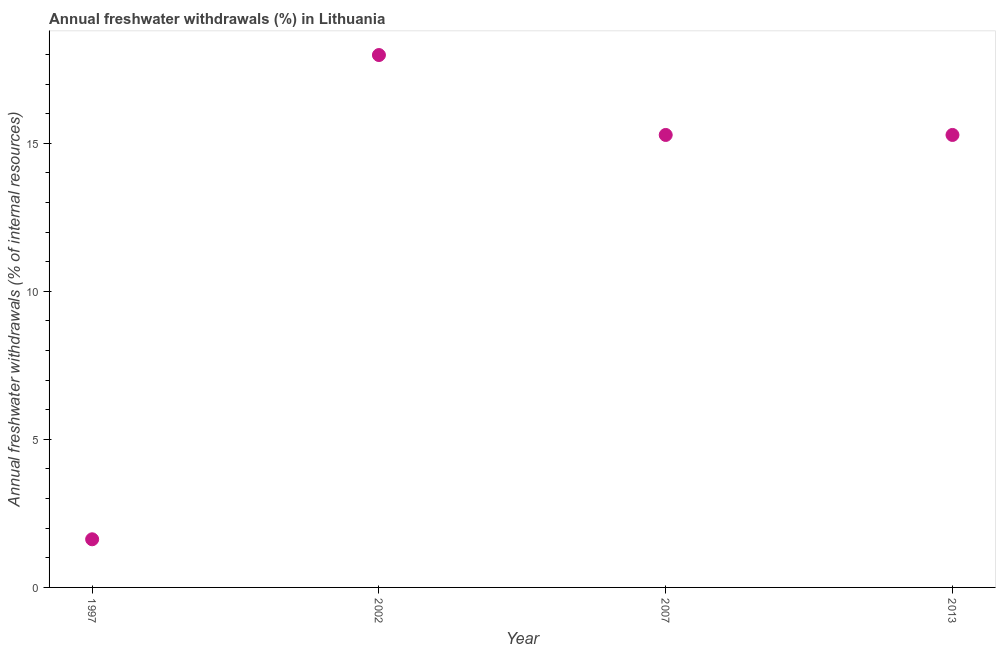What is the annual freshwater withdrawals in 2007?
Your response must be concise. 15.28. Across all years, what is the maximum annual freshwater withdrawals?
Provide a short and direct response. 17.98. Across all years, what is the minimum annual freshwater withdrawals?
Keep it short and to the point. 1.63. In which year was the annual freshwater withdrawals minimum?
Offer a terse response. 1997. What is the sum of the annual freshwater withdrawals?
Your answer should be compact. 50.17. What is the average annual freshwater withdrawals per year?
Offer a very short reply. 12.54. What is the median annual freshwater withdrawals?
Your answer should be compact. 15.28. In how many years, is the annual freshwater withdrawals greater than 13 %?
Your answer should be compact. 3. Is the annual freshwater withdrawals in 1997 less than that in 2002?
Make the answer very short. Yes. Is the difference between the annual freshwater withdrawals in 1997 and 2013 greater than the difference between any two years?
Offer a very short reply. No. What is the difference between the highest and the second highest annual freshwater withdrawals?
Provide a short and direct response. 2.7. What is the difference between the highest and the lowest annual freshwater withdrawals?
Make the answer very short. 16.36. Does the annual freshwater withdrawals monotonically increase over the years?
Offer a very short reply. No. How many dotlines are there?
Offer a terse response. 1. How many years are there in the graph?
Your response must be concise. 4. Are the values on the major ticks of Y-axis written in scientific E-notation?
Ensure brevity in your answer.  No. Does the graph contain grids?
Provide a succinct answer. No. What is the title of the graph?
Your response must be concise. Annual freshwater withdrawals (%) in Lithuania. What is the label or title of the Y-axis?
Provide a succinct answer. Annual freshwater withdrawals (% of internal resources). What is the Annual freshwater withdrawals (% of internal resources) in 1997?
Your answer should be very brief. 1.63. What is the Annual freshwater withdrawals (% of internal resources) in 2002?
Your response must be concise. 17.98. What is the Annual freshwater withdrawals (% of internal resources) in 2007?
Give a very brief answer. 15.28. What is the Annual freshwater withdrawals (% of internal resources) in 2013?
Your answer should be compact. 15.28. What is the difference between the Annual freshwater withdrawals (% of internal resources) in 1997 and 2002?
Your response must be concise. -16.36. What is the difference between the Annual freshwater withdrawals (% of internal resources) in 1997 and 2007?
Ensure brevity in your answer.  -13.66. What is the difference between the Annual freshwater withdrawals (% of internal resources) in 1997 and 2013?
Provide a short and direct response. -13.66. What is the difference between the Annual freshwater withdrawals (% of internal resources) in 2002 and 2007?
Provide a succinct answer. 2.7. What is the difference between the Annual freshwater withdrawals (% of internal resources) in 2002 and 2013?
Provide a succinct answer. 2.7. What is the ratio of the Annual freshwater withdrawals (% of internal resources) in 1997 to that in 2002?
Your response must be concise. 0.09. What is the ratio of the Annual freshwater withdrawals (% of internal resources) in 1997 to that in 2007?
Offer a very short reply. 0.11. What is the ratio of the Annual freshwater withdrawals (% of internal resources) in 1997 to that in 2013?
Make the answer very short. 0.11. What is the ratio of the Annual freshwater withdrawals (% of internal resources) in 2002 to that in 2007?
Your response must be concise. 1.18. What is the ratio of the Annual freshwater withdrawals (% of internal resources) in 2002 to that in 2013?
Provide a succinct answer. 1.18. 